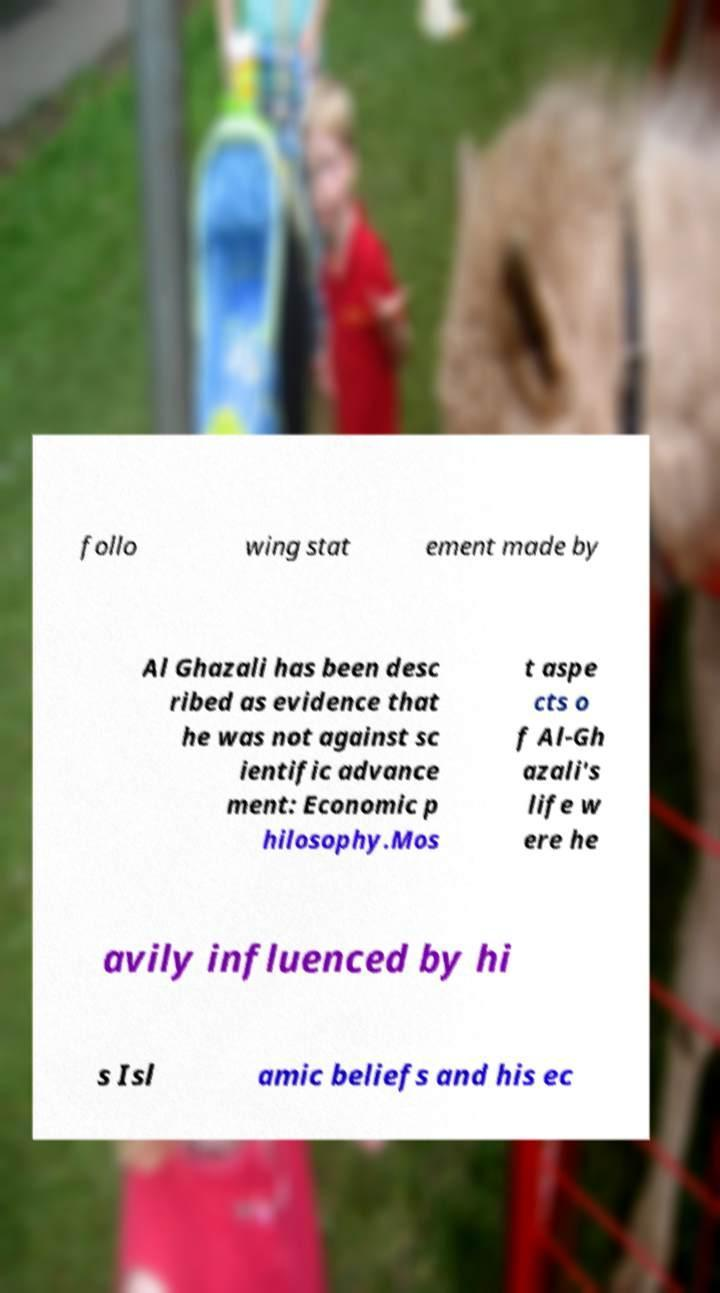What messages or text are displayed in this image? I need them in a readable, typed format. follo wing stat ement made by Al Ghazali has been desc ribed as evidence that he was not against sc ientific advance ment: Economic p hilosophy.Mos t aspe cts o f Al-Gh azali's life w ere he avily influenced by hi s Isl amic beliefs and his ec 